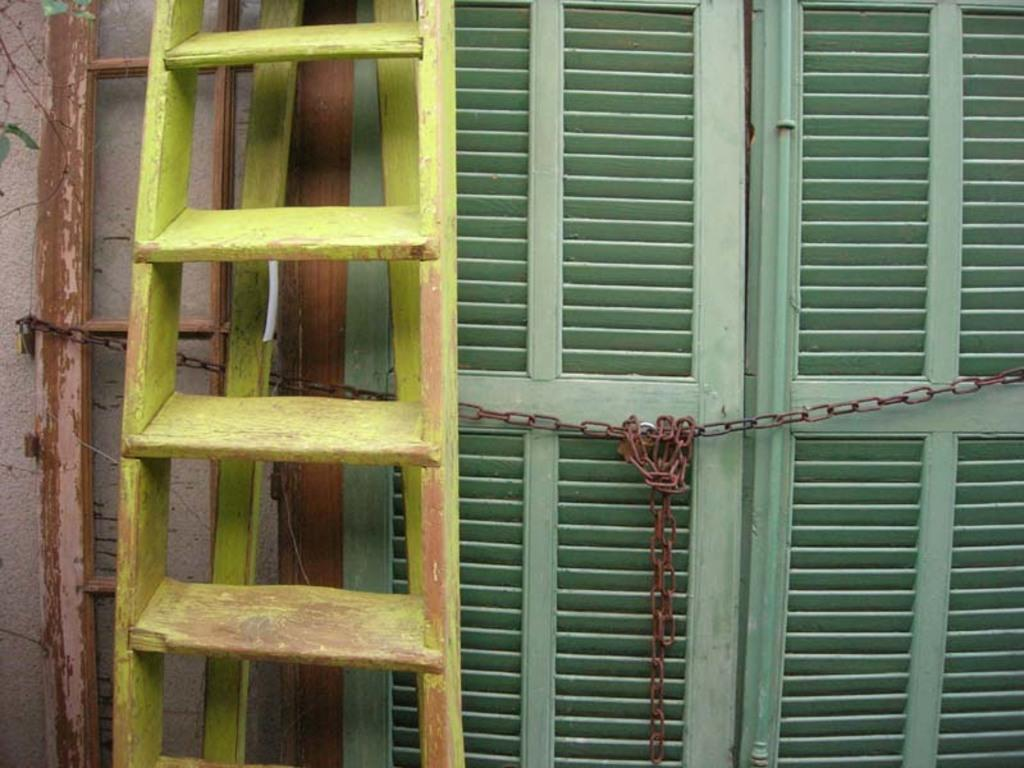What is attached to the wall on the left side of the image? There are ladders on the wall on the left side of the image. What object can be seen in the image that is typically used for connecting or securing things? There is a chain in the image. What type of architectural feature is present in the image? There are doors in the image. What type of property is being sold in the image? There is no indication in the image that a property is being sold. How many houses are visible in the image? There are no houses visible in the image. What action is being performed by the chain in the image? The chain is not performing any action in the image; it is simply present as an object. 